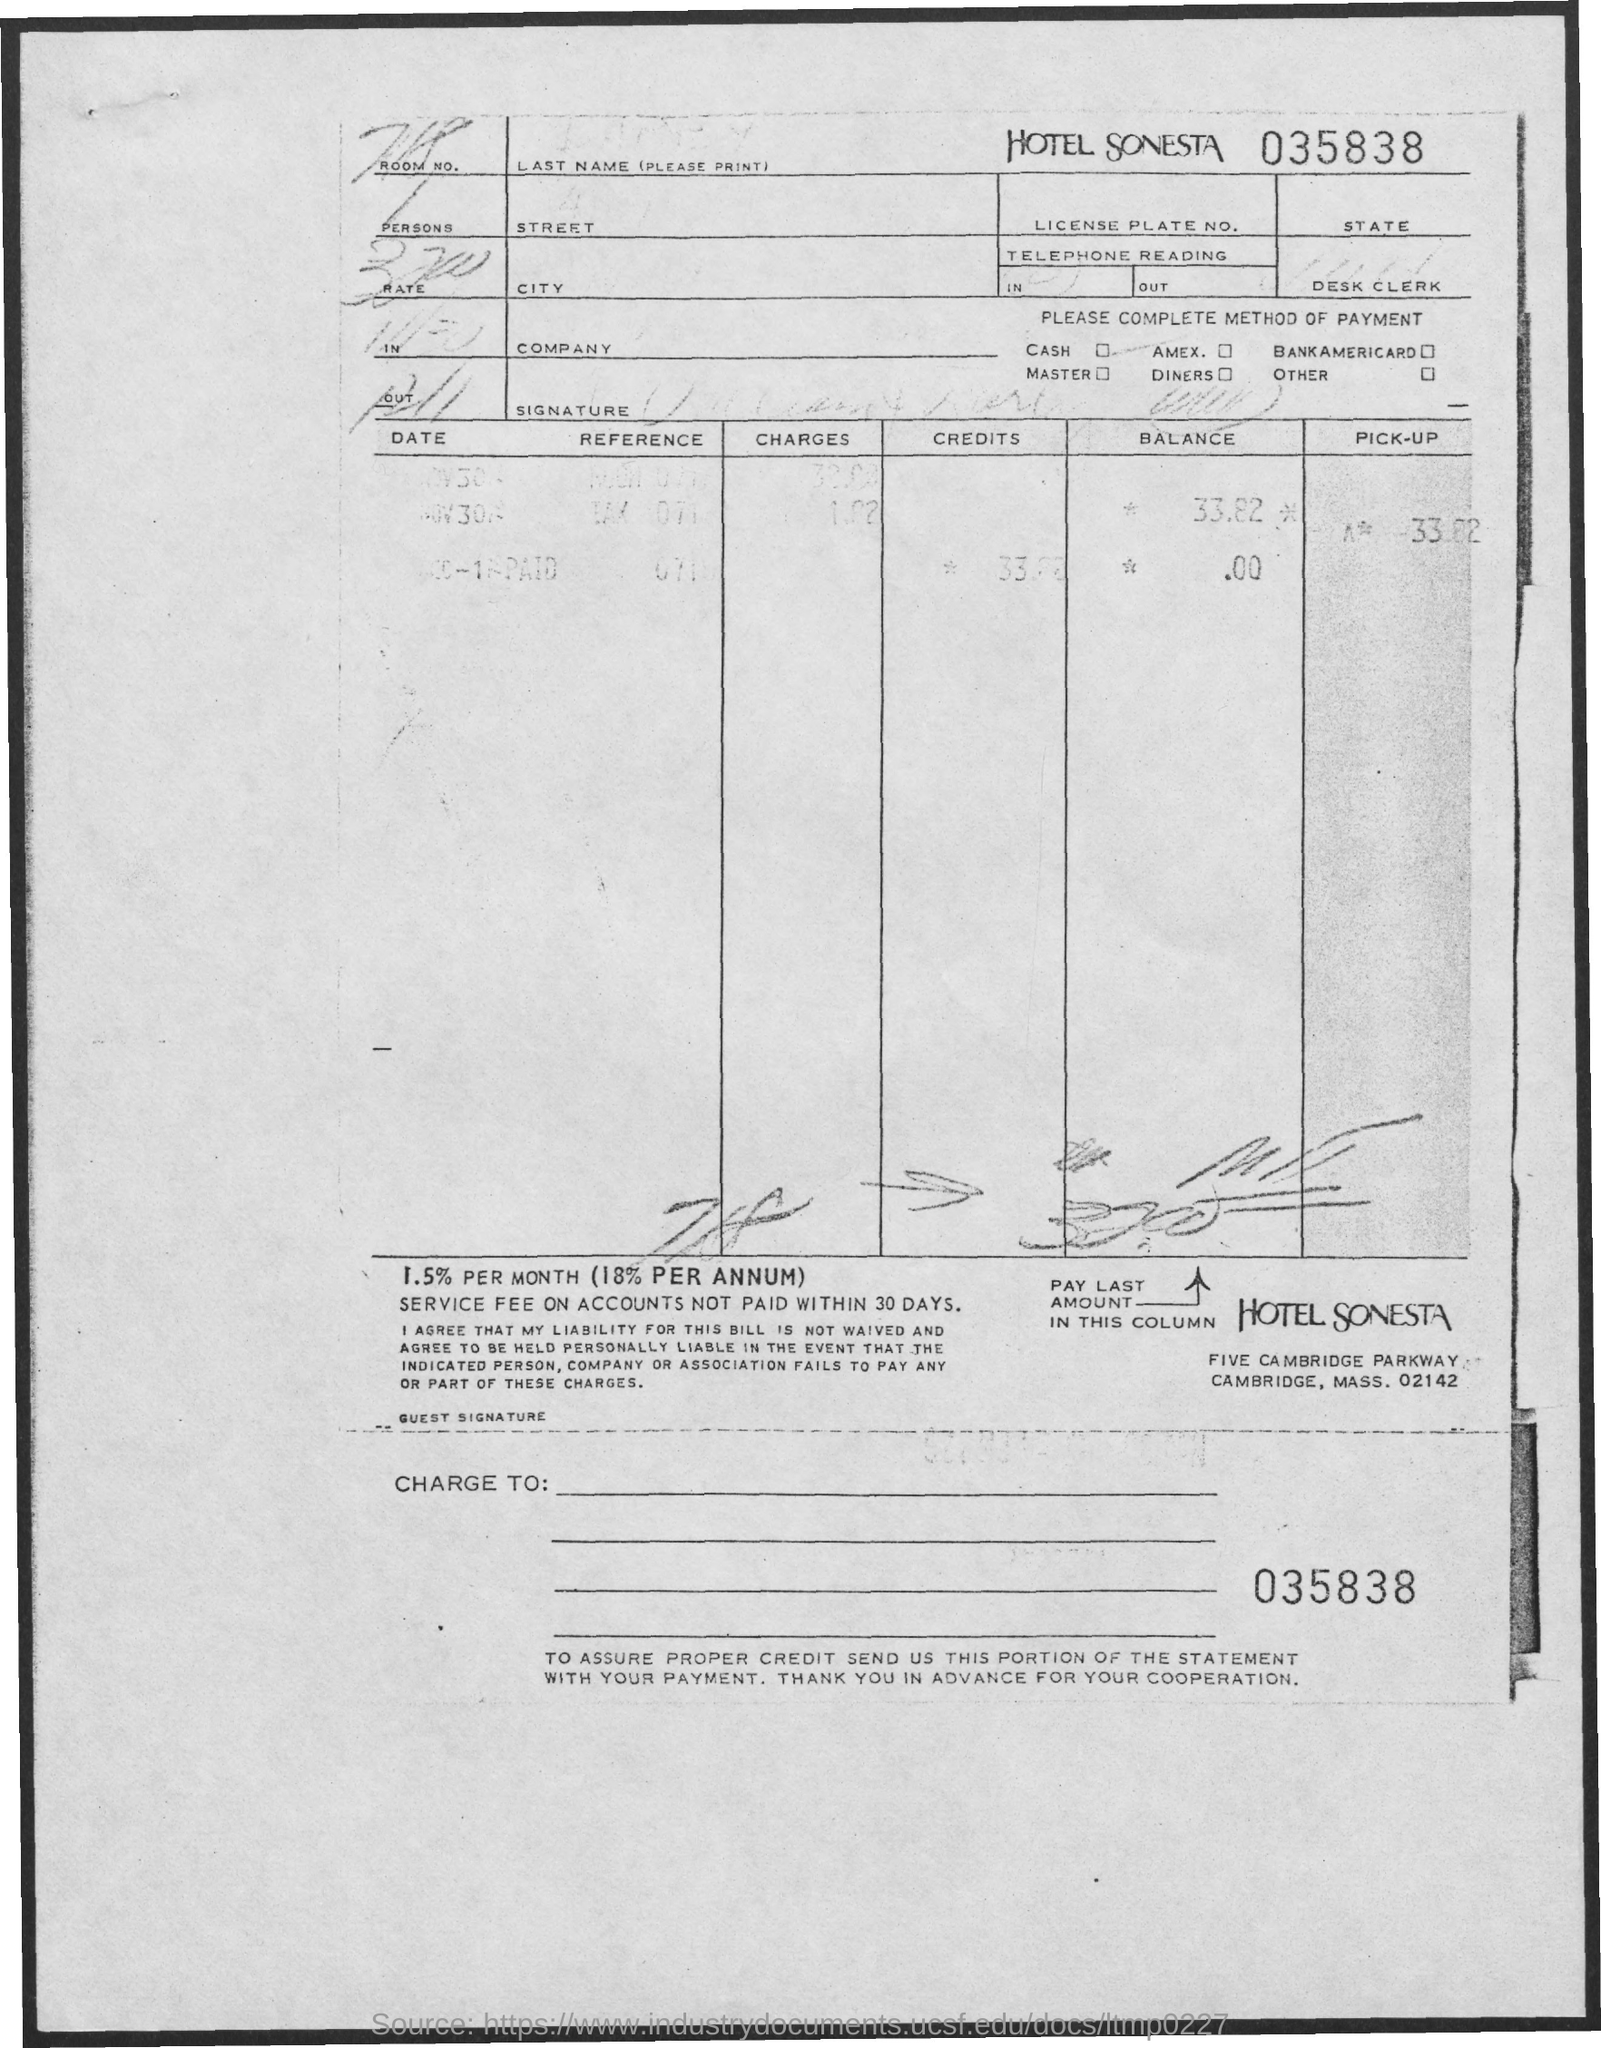Draw attention to some important aspects in this diagram. The hotel mentioned is Sonesta. 